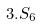Convert formula to latex. <formula><loc_0><loc_0><loc_500><loc_500>3 . S _ { 6 }</formula> 